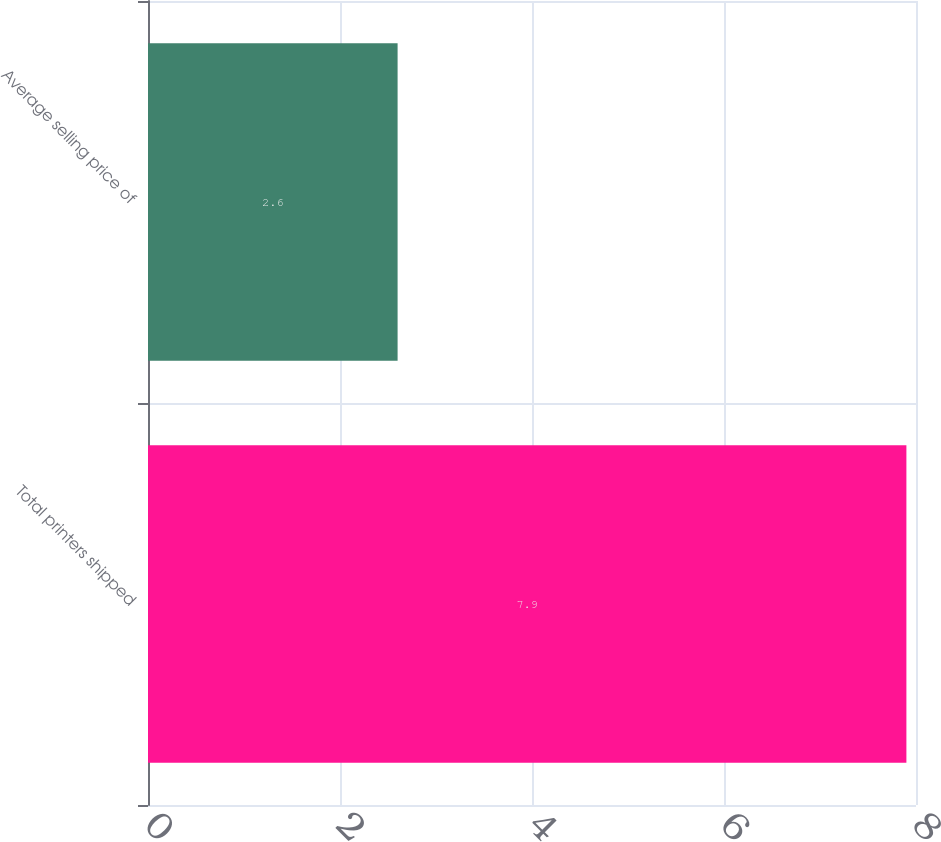Convert chart. <chart><loc_0><loc_0><loc_500><loc_500><bar_chart><fcel>Total printers shipped<fcel>Average selling price of<nl><fcel>7.9<fcel>2.6<nl></chart> 